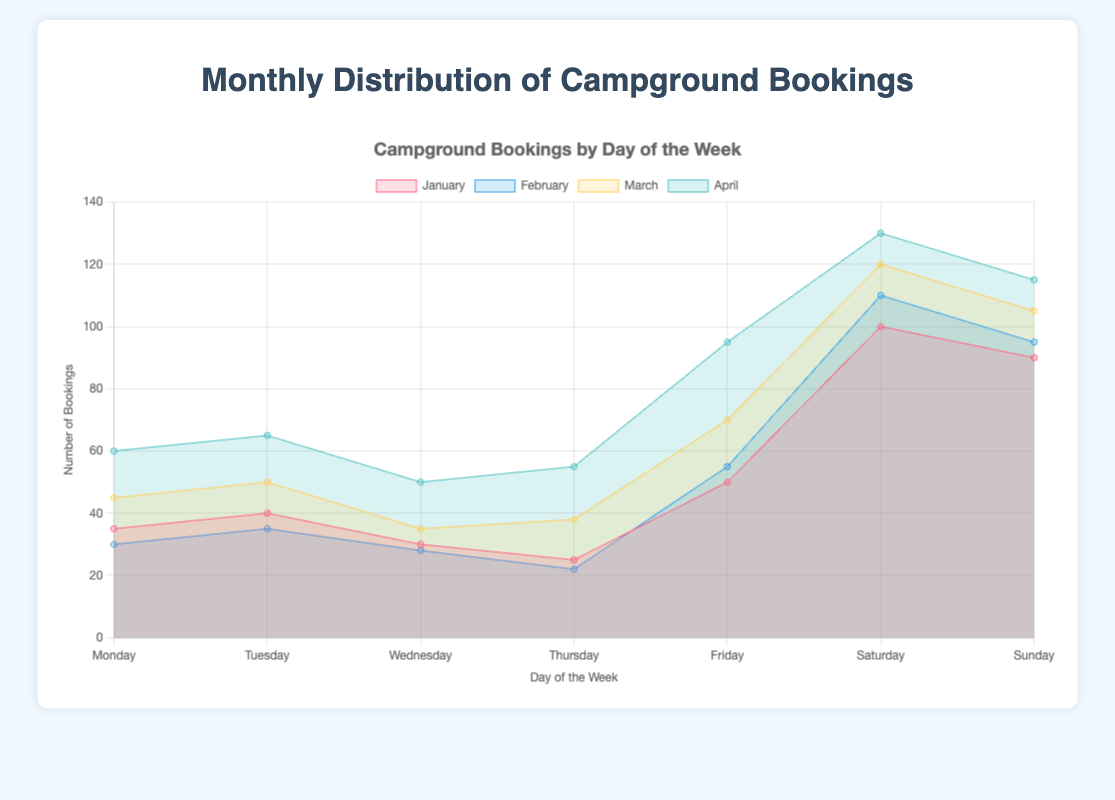What is the title of the chart? The title is typically displayed at the top of the chart. It reads "Monthly Distribution of Campground Bookings."
Answer: Monthly Distribution of Campground Bookings Which day of the week has the highest number of bookings in January? By examining the data for January, the highest value is found on Saturday with 100 bookings.
Answer: Saturday How many bookings are there on Thursdays in March? Referring to the data for March, the number of bookings on Thursday is listed as 38.
Answer: 38 Which month has the highest average number of bookings per day? To find the highest average, we will average the bookings for each month. January: (35+40+30+25+50+100+90)/7 = 52.86; February: (30+35+28+22+55+110+95)/7 = 53.57; March: (45+50+35+38+70+120+105)/7 = 66.14; April: (60+65+50+55+95+130+115)/7 = 81.43. April has the highest average.
Answer: April Which two days of the week consistently have the highest number of bookings across all months? By comparing the data for all months, Saturday and Sunday consistently have the highest numbers. January: 100, 90; February: 110, 95; March: 120, 105; April: 130, 115.
Answer: Saturday and Sunday Compare the number of bookings on Fridays between January and February. Which month has more? Referring to the data for Fridays, January has 50 bookings and February has 55. February has 5 more bookings than January.
Answer: February What is the total number of bookings for Wednesdays in the dataset? Sum the bookings on Wednesdays across all months: January (30) + February (28) + March (35) + April (50) = 143.
Answer: 143 How does the trend in bookings from Monday to Sunday change from January to April? January shows an increasing trend towards the weekend, peaking on Saturday (100) and dropping slightly on Sunday (90). February follows a similar pattern, with a slight increase on Saturday (110) and Sunday (95). March and April show a stronger increase towards the weekend, with peaks on Saturday (120 and 130) and Sunday (105 and 115), respectively, indicating a consistent weekend peak in bookings.
Answer: Consistent weekend peaks in bookings What is the increase in the number of Monday bookings from January to April? Subtract the number of Monday bookings in January (35) from April (60): 60 - 35 = 25.
Answer: 25 What is the largest difference in bookings for any single day of the week across all months? Calculate the differences for each day: Monday (60-30=30), Tuesday (65-35=30), Wednesday (50-28=22), Thursday (55-22=33), Friday (95-50=45), Saturday (130-100=30), Sunday (115-90=25). The largest difference is on Friday with 45 bookings.
Answer: Friday 